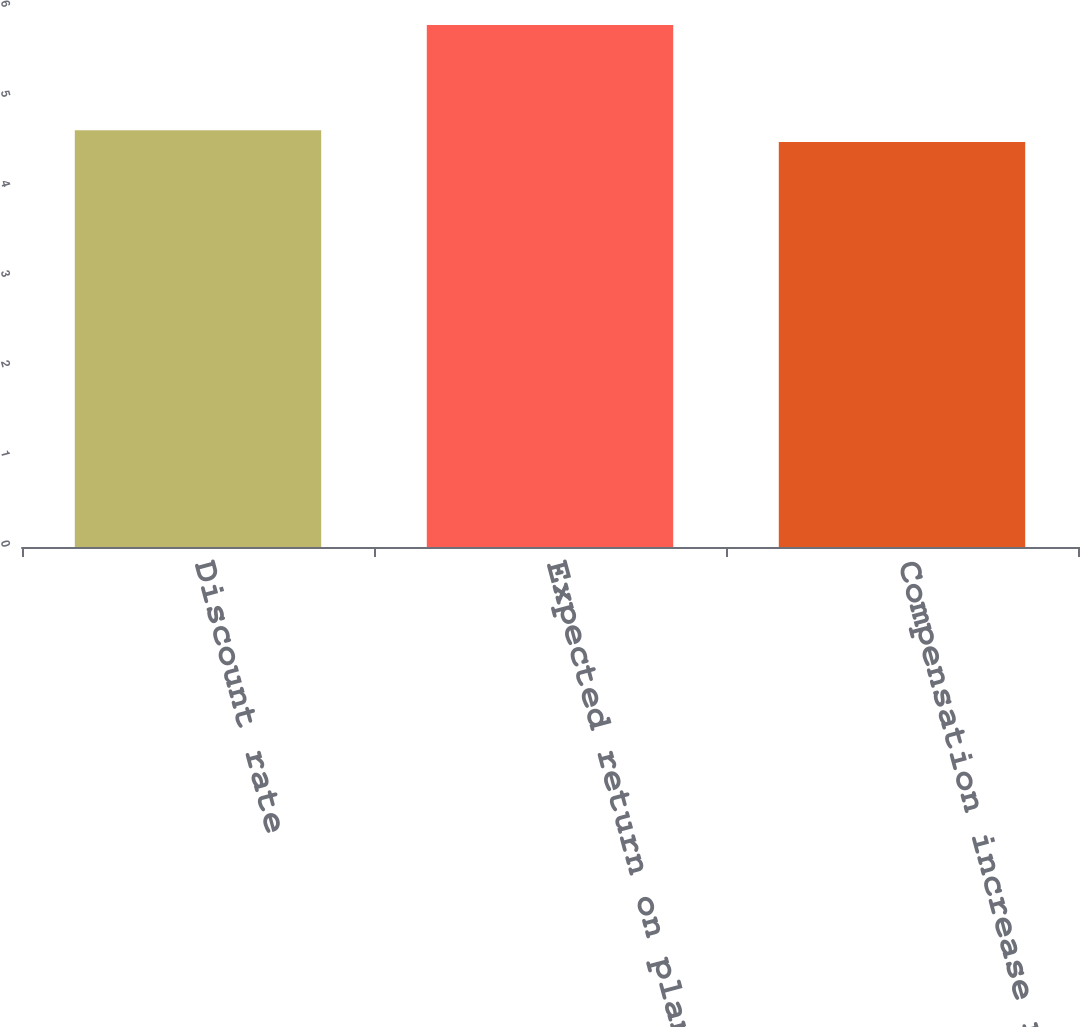Convert chart to OTSL. <chart><loc_0><loc_0><loc_500><loc_500><bar_chart><fcel>Discount rate<fcel>Expected return on plan assets<fcel>Compensation increase rate<nl><fcel>4.63<fcel>5.8<fcel>4.5<nl></chart> 